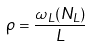<formula> <loc_0><loc_0><loc_500><loc_500>\rho = \frac { \omega _ { L } ( N _ { L } ) } { L }</formula> 